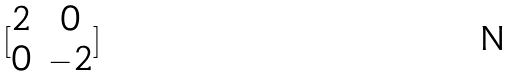Convert formula to latex. <formula><loc_0><loc_0><loc_500><loc_500>[ \begin{matrix} 2 & 0 \\ 0 & - 2 \end{matrix} ]</formula> 